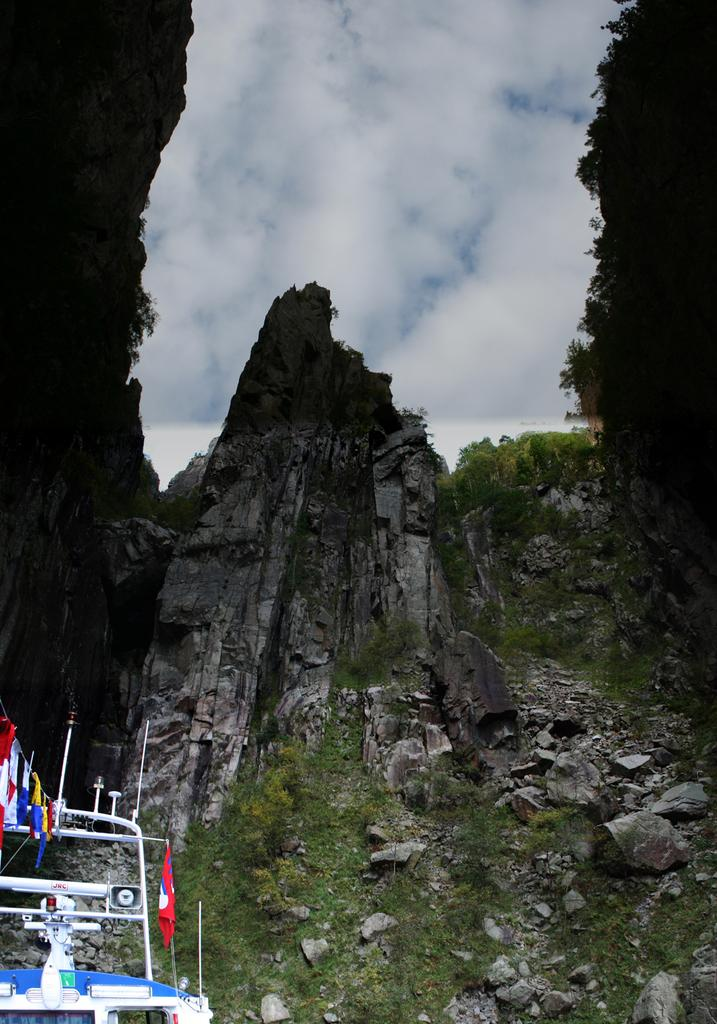What is the main subject of the image? The main subject of the image is a boat. What decorative elements are present on the boat? There are flags on the boat. What can be said about the appearance of the flags? The flags are colorful. What can be seen in the background of the image? The sky is visible in the image. What type of vegetation is present in the image? There are plants in the image. Can you describe the glass used to build the boat in the image? There is no mention of glass being used to build the boat in the image. The boat appears to be made of a different material, such as wood or metal. Is there a bear visible in the image? No, there is no bear present in the image. The image features a boat with flags and plants in the background. 